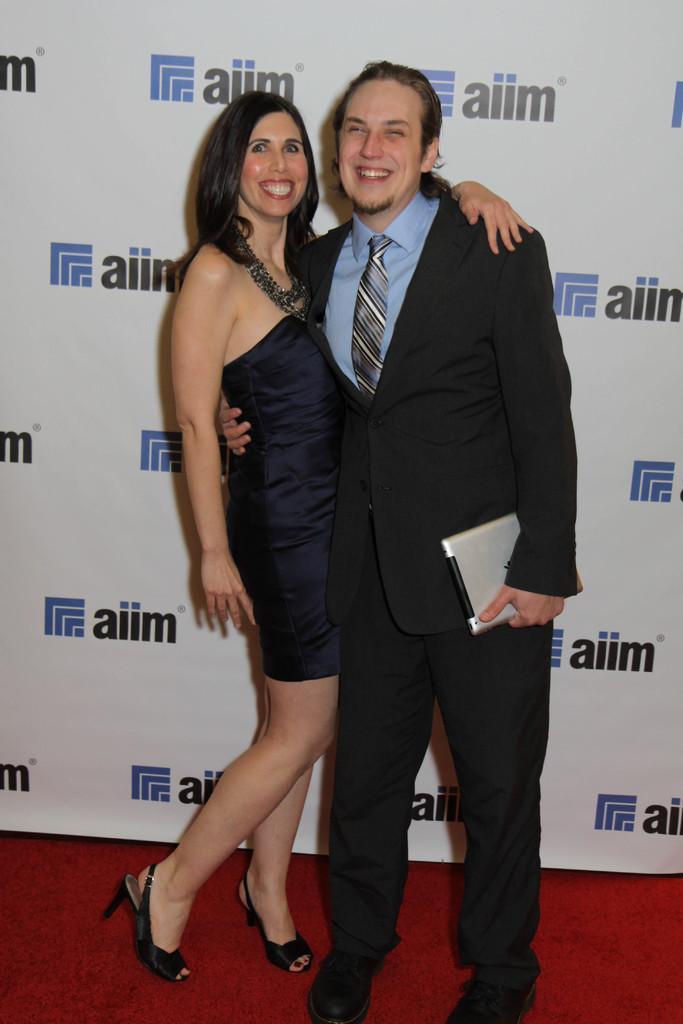Can you describe this image briefly? In the center of the picture there is a man and a woman standing, behind them there is a banner. At the bottom there is red carpet. 